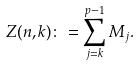<formula> <loc_0><loc_0><loc_500><loc_500>Z ( n , k ) \colon = \sum _ { j = k } ^ { p - 1 } M _ { j } .</formula> 